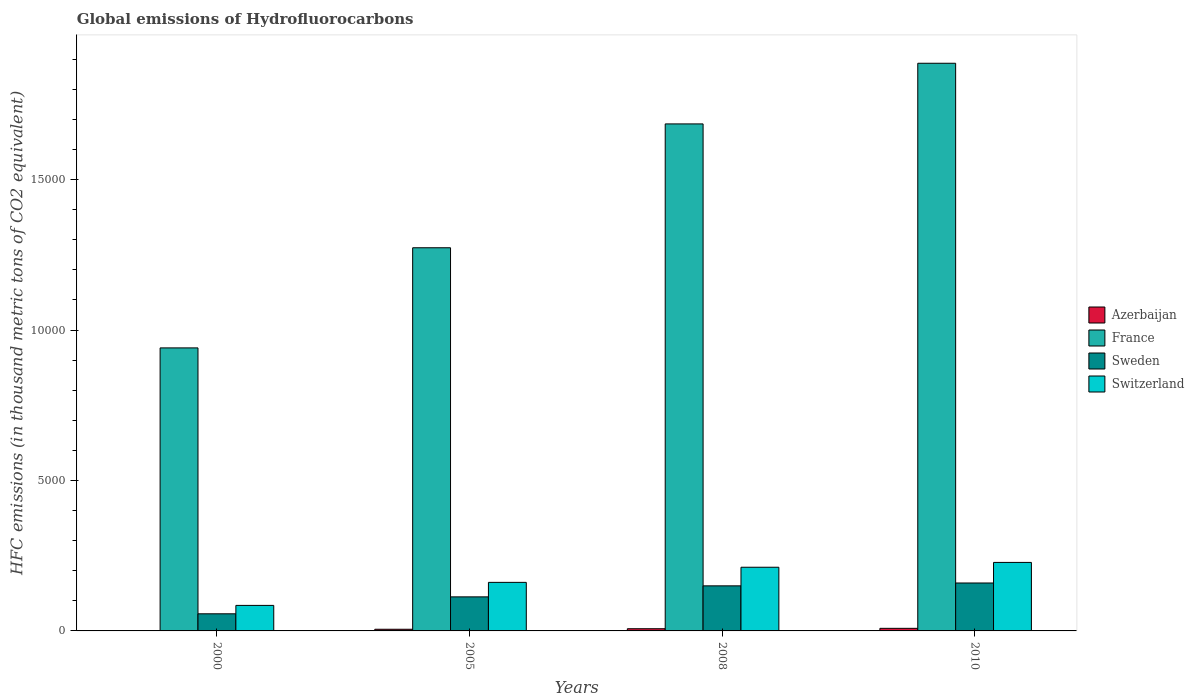How many groups of bars are there?
Offer a terse response. 4. Are the number of bars per tick equal to the number of legend labels?
Your response must be concise. Yes. Are the number of bars on each tick of the X-axis equal?
Offer a terse response. Yes. What is the label of the 1st group of bars from the left?
Keep it short and to the point. 2000. In how many cases, is the number of bars for a given year not equal to the number of legend labels?
Give a very brief answer. 0. What is the global emissions of Hydrofluorocarbons in Switzerland in 2010?
Offer a very short reply. 2277. Across all years, what is the minimum global emissions of Hydrofluorocarbons in Sweden?
Ensure brevity in your answer.  568.8. What is the total global emissions of Hydrofluorocarbons in Switzerland in the graph?
Ensure brevity in your answer.  6855.4. What is the difference between the global emissions of Hydrofluorocarbons in Azerbaijan in 2000 and that in 2008?
Offer a terse response. -64.6. What is the difference between the global emissions of Hydrofluorocarbons in Switzerland in 2000 and the global emissions of Hydrofluorocarbons in Sweden in 2008?
Your answer should be very brief. -649.8. What is the average global emissions of Hydrofluorocarbons in Switzerland per year?
Your answer should be compact. 1713.85. In the year 2010, what is the difference between the global emissions of Hydrofluorocarbons in Switzerland and global emissions of Hydrofluorocarbons in Azerbaijan?
Ensure brevity in your answer.  2191. What is the ratio of the global emissions of Hydrofluorocarbons in Azerbaijan in 2000 to that in 2005?
Make the answer very short. 0.15. Is the difference between the global emissions of Hydrofluorocarbons in Switzerland in 2000 and 2005 greater than the difference between the global emissions of Hydrofluorocarbons in Azerbaijan in 2000 and 2005?
Your answer should be very brief. No. What is the difference between the highest and the second highest global emissions of Hydrofluorocarbons in Azerbaijan?
Your answer should be compact. 12.9. What is the difference between the highest and the lowest global emissions of Hydrofluorocarbons in Switzerland?
Offer a very short reply. 1428.8. In how many years, is the global emissions of Hydrofluorocarbons in France greater than the average global emissions of Hydrofluorocarbons in France taken over all years?
Make the answer very short. 2. Is it the case that in every year, the sum of the global emissions of Hydrofluorocarbons in Azerbaijan and global emissions of Hydrofluorocarbons in Switzerland is greater than the sum of global emissions of Hydrofluorocarbons in Sweden and global emissions of Hydrofluorocarbons in France?
Your response must be concise. Yes. What does the 1st bar from the left in 2005 represents?
Give a very brief answer. Azerbaijan. Are all the bars in the graph horizontal?
Your answer should be very brief. No. Are the values on the major ticks of Y-axis written in scientific E-notation?
Give a very brief answer. No. Does the graph contain any zero values?
Your response must be concise. No. What is the title of the graph?
Make the answer very short. Global emissions of Hydrofluorocarbons. What is the label or title of the Y-axis?
Keep it short and to the point. HFC emissions (in thousand metric tons of CO2 equivalent). What is the HFC emissions (in thousand metric tons of CO2 equivalent) in Azerbaijan in 2000?
Provide a succinct answer. 8.5. What is the HFC emissions (in thousand metric tons of CO2 equivalent) in France in 2000?
Keep it short and to the point. 9406.4. What is the HFC emissions (in thousand metric tons of CO2 equivalent) of Sweden in 2000?
Keep it short and to the point. 568.8. What is the HFC emissions (in thousand metric tons of CO2 equivalent) of Switzerland in 2000?
Your response must be concise. 848.2. What is the HFC emissions (in thousand metric tons of CO2 equivalent) in Azerbaijan in 2005?
Offer a very short reply. 55.4. What is the HFC emissions (in thousand metric tons of CO2 equivalent) in France in 2005?
Keep it short and to the point. 1.27e+04. What is the HFC emissions (in thousand metric tons of CO2 equivalent) in Sweden in 2005?
Ensure brevity in your answer.  1131.9. What is the HFC emissions (in thousand metric tons of CO2 equivalent) in Switzerland in 2005?
Make the answer very short. 1613.8. What is the HFC emissions (in thousand metric tons of CO2 equivalent) in Azerbaijan in 2008?
Make the answer very short. 73.1. What is the HFC emissions (in thousand metric tons of CO2 equivalent) of France in 2008?
Provide a short and direct response. 1.69e+04. What is the HFC emissions (in thousand metric tons of CO2 equivalent) of Sweden in 2008?
Ensure brevity in your answer.  1498. What is the HFC emissions (in thousand metric tons of CO2 equivalent) of Switzerland in 2008?
Provide a succinct answer. 2116.4. What is the HFC emissions (in thousand metric tons of CO2 equivalent) of France in 2010?
Your response must be concise. 1.89e+04. What is the HFC emissions (in thousand metric tons of CO2 equivalent) in Sweden in 2010?
Give a very brief answer. 1593. What is the HFC emissions (in thousand metric tons of CO2 equivalent) in Switzerland in 2010?
Ensure brevity in your answer.  2277. Across all years, what is the maximum HFC emissions (in thousand metric tons of CO2 equivalent) of Azerbaijan?
Ensure brevity in your answer.  86. Across all years, what is the maximum HFC emissions (in thousand metric tons of CO2 equivalent) in France?
Offer a terse response. 1.89e+04. Across all years, what is the maximum HFC emissions (in thousand metric tons of CO2 equivalent) of Sweden?
Your answer should be very brief. 1593. Across all years, what is the maximum HFC emissions (in thousand metric tons of CO2 equivalent) of Switzerland?
Your answer should be very brief. 2277. Across all years, what is the minimum HFC emissions (in thousand metric tons of CO2 equivalent) in Azerbaijan?
Give a very brief answer. 8.5. Across all years, what is the minimum HFC emissions (in thousand metric tons of CO2 equivalent) of France?
Your answer should be compact. 9406.4. Across all years, what is the minimum HFC emissions (in thousand metric tons of CO2 equivalent) of Sweden?
Provide a succinct answer. 568.8. Across all years, what is the minimum HFC emissions (in thousand metric tons of CO2 equivalent) of Switzerland?
Your response must be concise. 848.2. What is the total HFC emissions (in thousand metric tons of CO2 equivalent) in Azerbaijan in the graph?
Your answer should be compact. 223. What is the total HFC emissions (in thousand metric tons of CO2 equivalent) in France in the graph?
Offer a terse response. 5.79e+04. What is the total HFC emissions (in thousand metric tons of CO2 equivalent) of Sweden in the graph?
Your answer should be very brief. 4791.7. What is the total HFC emissions (in thousand metric tons of CO2 equivalent) in Switzerland in the graph?
Provide a short and direct response. 6855.4. What is the difference between the HFC emissions (in thousand metric tons of CO2 equivalent) of Azerbaijan in 2000 and that in 2005?
Make the answer very short. -46.9. What is the difference between the HFC emissions (in thousand metric tons of CO2 equivalent) in France in 2000 and that in 2005?
Keep it short and to the point. -3328.3. What is the difference between the HFC emissions (in thousand metric tons of CO2 equivalent) in Sweden in 2000 and that in 2005?
Provide a short and direct response. -563.1. What is the difference between the HFC emissions (in thousand metric tons of CO2 equivalent) in Switzerland in 2000 and that in 2005?
Your answer should be compact. -765.6. What is the difference between the HFC emissions (in thousand metric tons of CO2 equivalent) of Azerbaijan in 2000 and that in 2008?
Offer a very short reply. -64.6. What is the difference between the HFC emissions (in thousand metric tons of CO2 equivalent) in France in 2000 and that in 2008?
Offer a very short reply. -7444.7. What is the difference between the HFC emissions (in thousand metric tons of CO2 equivalent) in Sweden in 2000 and that in 2008?
Make the answer very short. -929.2. What is the difference between the HFC emissions (in thousand metric tons of CO2 equivalent) of Switzerland in 2000 and that in 2008?
Your response must be concise. -1268.2. What is the difference between the HFC emissions (in thousand metric tons of CO2 equivalent) in Azerbaijan in 2000 and that in 2010?
Offer a very short reply. -77.5. What is the difference between the HFC emissions (in thousand metric tons of CO2 equivalent) in France in 2000 and that in 2010?
Provide a succinct answer. -9460.6. What is the difference between the HFC emissions (in thousand metric tons of CO2 equivalent) in Sweden in 2000 and that in 2010?
Your answer should be very brief. -1024.2. What is the difference between the HFC emissions (in thousand metric tons of CO2 equivalent) of Switzerland in 2000 and that in 2010?
Provide a succinct answer. -1428.8. What is the difference between the HFC emissions (in thousand metric tons of CO2 equivalent) of Azerbaijan in 2005 and that in 2008?
Offer a terse response. -17.7. What is the difference between the HFC emissions (in thousand metric tons of CO2 equivalent) of France in 2005 and that in 2008?
Give a very brief answer. -4116.4. What is the difference between the HFC emissions (in thousand metric tons of CO2 equivalent) of Sweden in 2005 and that in 2008?
Offer a very short reply. -366.1. What is the difference between the HFC emissions (in thousand metric tons of CO2 equivalent) of Switzerland in 2005 and that in 2008?
Your response must be concise. -502.6. What is the difference between the HFC emissions (in thousand metric tons of CO2 equivalent) in Azerbaijan in 2005 and that in 2010?
Your answer should be compact. -30.6. What is the difference between the HFC emissions (in thousand metric tons of CO2 equivalent) in France in 2005 and that in 2010?
Give a very brief answer. -6132.3. What is the difference between the HFC emissions (in thousand metric tons of CO2 equivalent) in Sweden in 2005 and that in 2010?
Give a very brief answer. -461.1. What is the difference between the HFC emissions (in thousand metric tons of CO2 equivalent) in Switzerland in 2005 and that in 2010?
Your answer should be very brief. -663.2. What is the difference between the HFC emissions (in thousand metric tons of CO2 equivalent) of France in 2008 and that in 2010?
Offer a very short reply. -2015.9. What is the difference between the HFC emissions (in thousand metric tons of CO2 equivalent) in Sweden in 2008 and that in 2010?
Make the answer very short. -95. What is the difference between the HFC emissions (in thousand metric tons of CO2 equivalent) in Switzerland in 2008 and that in 2010?
Ensure brevity in your answer.  -160.6. What is the difference between the HFC emissions (in thousand metric tons of CO2 equivalent) in Azerbaijan in 2000 and the HFC emissions (in thousand metric tons of CO2 equivalent) in France in 2005?
Offer a terse response. -1.27e+04. What is the difference between the HFC emissions (in thousand metric tons of CO2 equivalent) in Azerbaijan in 2000 and the HFC emissions (in thousand metric tons of CO2 equivalent) in Sweden in 2005?
Ensure brevity in your answer.  -1123.4. What is the difference between the HFC emissions (in thousand metric tons of CO2 equivalent) of Azerbaijan in 2000 and the HFC emissions (in thousand metric tons of CO2 equivalent) of Switzerland in 2005?
Offer a terse response. -1605.3. What is the difference between the HFC emissions (in thousand metric tons of CO2 equivalent) in France in 2000 and the HFC emissions (in thousand metric tons of CO2 equivalent) in Sweden in 2005?
Give a very brief answer. 8274.5. What is the difference between the HFC emissions (in thousand metric tons of CO2 equivalent) of France in 2000 and the HFC emissions (in thousand metric tons of CO2 equivalent) of Switzerland in 2005?
Provide a succinct answer. 7792.6. What is the difference between the HFC emissions (in thousand metric tons of CO2 equivalent) in Sweden in 2000 and the HFC emissions (in thousand metric tons of CO2 equivalent) in Switzerland in 2005?
Provide a succinct answer. -1045. What is the difference between the HFC emissions (in thousand metric tons of CO2 equivalent) of Azerbaijan in 2000 and the HFC emissions (in thousand metric tons of CO2 equivalent) of France in 2008?
Ensure brevity in your answer.  -1.68e+04. What is the difference between the HFC emissions (in thousand metric tons of CO2 equivalent) in Azerbaijan in 2000 and the HFC emissions (in thousand metric tons of CO2 equivalent) in Sweden in 2008?
Offer a terse response. -1489.5. What is the difference between the HFC emissions (in thousand metric tons of CO2 equivalent) of Azerbaijan in 2000 and the HFC emissions (in thousand metric tons of CO2 equivalent) of Switzerland in 2008?
Your answer should be very brief. -2107.9. What is the difference between the HFC emissions (in thousand metric tons of CO2 equivalent) of France in 2000 and the HFC emissions (in thousand metric tons of CO2 equivalent) of Sweden in 2008?
Your answer should be very brief. 7908.4. What is the difference between the HFC emissions (in thousand metric tons of CO2 equivalent) in France in 2000 and the HFC emissions (in thousand metric tons of CO2 equivalent) in Switzerland in 2008?
Keep it short and to the point. 7290. What is the difference between the HFC emissions (in thousand metric tons of CO2 equivalent) in Sweden in 2000 and the HFC emissions (in thousand metric tons of CO2 equivalent) in Switzerland in 2008?
Your answer should be very brief. -1547.6. What is the difference between the HFC emissions (in thousand metric tons of CO2 equivalent) of Azerbaijan in 2000 and the HFC emissions (in thousand metric tons of CO2 equivalent) of France in 2010?
Provide a succinct answer. -1.89e+04. What is the difference between the HFC emissions (in thousand metric tons of CO2 equivalent) of Azerbaijan in 2000 and the HFC emissions (in thousand metric tons of CO2 equivalent) of Sweden in 2010?
Ensure brevity in your answer.  -1584.5. What is the difference between the HFC emissions (in thousand metric tons of CO2 equivalent) in Azerbaijan in 2000 and the HFC emissions (in thousand metric tons of CO2 equivalent) in Switzerland in 2010?
Give a very brief answer. -2268.5. What is the difference between the HFC emissions (in thousand metric tons of CO2 equivalent) in France in 2000 and the HFC emissions (in thousand metric tons of CO2 equivalent) in Sweden in 2010?
Make the answer very short. 7813.4. What is the difference between the HFC emissions (in thousand metric tons of CO2 equivalent) in France in 2000 and the HFC emissions (in thousand metric tons of CO2 equivalent) in Switzerland in 2010?
Ensure brevity in your answer.  7129.4. What is the difference between the HFC emissions (in thousand metric tons of CO2 equivalent) of Sweden in 2000 and the HFC emissions (in thousand metric tons of CO2 equivalent) of Switzerland in 2010?
Offer a very short reply. -1708.2. What is the difference between the HFC emissions (in thousand metric tons of CO2 equivalent) of Azerbaijan in 2005 and the HFC emissions (in thousand metric tons of CO2 equivalent) of France in 2008?
Offer a very short reply. -1.68e+04. What is the difference between the HFC emissions (in thousand metric tons of CO2 equivalent) of Azerbaijan in 2005 and the HFC emissions (in thousand metric tons of CO2 equivalent) of Sweden in 2008?
Provide a short and direct response. -1442.6. What is the difference between the HFC emissions (in thousand metric tons of CO2 equivalent) in Azerbaijan in 2005 and the HFC emissions (in thousand metric tons of CO2 equivalent) in Switzerland in 2008?
Offer a very short reply. -2061. What is the difference between the HFC emissions (in thousand metric tons of CO2 equivalent) in France in 2005 and the HFC emissions (in thousand metric tons of CO2 equivalent) in Sweden in 2008?
Ensure brevity in your answer.  1.12e+04. What is the difference between the HFC emissions (in thousand metric tons of CO2 equivalent) of France in 2005 and the HFC emissions (in thousand metric tons of CO2 equivalent) of Switzerland in 2008?
Provide a short and direct response. 1.06e+04. What is the difference between the HFC emissions (in thousand metric tons of CO2 equivalent) of Sweden in 2005 and the HFC emissions (in thousand metric tons of CO2 equivalent) of Switzerland in 2008?
Provide a short and direct response. -984.5. What is the difference between the HFC emissions (in thousand metric tons of CO2 equivalent) in Azerbaijan in 2005 and the HFC emissions (in thousand metric tons of CO2 equivalent) in France in 2010?
Make the answer very short. -1.88e+04. What is the difference between the HFC emissions (in thousand metric tons of CO2 equivalent) of Azerbaijan in 2005 and the HFC emissions (in thousand metric tons of CO2 equivalent) of Sweden in 2010?
Offer a very short reply. -1537.6. What is the difference between the HFC emissions (in thousand metric tons of CO2 equivalent) in Azerbaijan in 2005 and the HFC emissions (in thousand metric tons of CO2 equivalent) in Switzerland in 2010?
Ensure brevity in your answer.  -2221.6. What is the difference between the HFC emissions (in thousand metric tons of CO2 equivalent) of France in 2005 and the HFC emissions (in thousand metric tons of CO2 equivalent) of Sweden in 2010?
Provide a short and direct response. 1.11e+04. What is the difference between the HFC emissions (in thousand metric tons of CO2 equivalent) in France in 2005 and the HFC emissions (in thousand metric tons of CO2 equivalent) in Switzerland in 2010?
Provide a short and direct response. 1.05e+04. What is the difference between the HFC emissions (in thousand metric tons of CO2 equivalent) of Sweden in 2005 and the HFC emissions (in thousand metric tons of CO2 equivalent) of Switzerland in 2010?
Your answer should be very brief. -1145.1. What is the difference between the HFC emissions (in thousand metric tons of CO2 equivalent) in Azerbaijan in 2008 and the HFC emissions (in thousand metric tons of CO2 equivalent) in France in 2010?
Make the answer very short. -1.88e+04. What is the difference between the HFC emissions (in thousand metric tons of CO2 equivalent) in Azerbaijan in 2008 and the HFC emissions (in thousand metric tons of CO2 equivalent) in Sweden in 2010?
Offer a terse response. -1519.9. What is the difference between the HFC emissions (in thousand metric tons of CO2 equivalent) in Azerbaijan in 2008 and the HFC emissions (in thousand metric tons of CO2 equivalent) in Switzerland in 2010?
Keep it short and to the point. -2203.9. What is the difference between the HFC emissions (in thousand metric tons of CO2 equivalent) in France in 2008 and the HFC emissions (in thousand metric tons of CO2 equivalent) in Sweden in 2010?
Provide a short and direct response. 1.53e+04. What is the difference between the HFC emissions (in thousand metric tons of CO2 equivalent) in France in 2008 and the HFC emissions (in thousand metric tons of CO2 equivalent) in Switzerland in 2010?
Your answer should be very brief. 1.46e+04. What is the difference between the HFC emissions (in thousand metric tons of CO2 equivalent) of Sweden in 2008 and the HFC emissions (in thousand metric tons of CO2 equivalent) of Switzerland in 2010?
Your response must be concise. -779. What is the average HFC emissions (in thousand metric tons of CO2 equivalent) of Azerbaijan per year?
Your answer should be very brief. 55.75. What is the average HFC emissions (in thousand metric tons of CO2 equivalent) in France per year?
Give a very brief answer. 1.45e+04. What is the average HFC emissions (in thousand metric tons of CO2 equivalent) of Sweden per year?
Your answer should be very brief. 1197.92. What is the average HFC emissions (in thousand metric tons of CO2 equivalent) of Switzerland per year?
Provide a succinct answer. 1713.85. In the year 2000, what is the difference between the HFC emissions (in thousand metric tons of CO2 equivalent) of Azerbaijan and HFC emissions (in thousand metric tons of CO2 equivalent) of France?
Make the answer very short. -9397.9. In the year 2000, what is the difference between the HFC emissions (in thousand metric tons of CO2 equivalent) of Azerbaijan and HFC emissions (in thousand metric tons of CO2 equivalent) of Sweden?
Offer a very short reply. -560.3. In the year 2000, what is the difference between the HFC emissions (in thousand metric tons of CO2 equivalent) of Azerbaijan and HFC emissions (in thousand metric tons of CO2 equivalent) of Switzerland?
Offer a terse response. -839.7. In the year 2000, what is the difference between the HFC emissions (in thousand metric tons of CO2 equivalent) in France and HFC emissions (in thousand metric tons of CO2 equivalent) in Sweden?
Your answer should be compact. 8837.6. In the year 2000, what is the difference between the HFC emissions (in thousand metric tons of CO2 equivalent) in France and HFC emissions (in thousand metric tons of CO2 equivalent) in Switzerland?
Your answer should be very brief. 8558.2. In the year 2000, what is the difference between the HFC emissions (in thousand metric tons of CO2 equivalent) in Sweden and HFC emissions (in thousand metric tons of CO2 equivalent) in Switzerland?
Provide a short and direct response. -279.4. In the year 2005, what is the difference between the HFC emissions (in thousand metric tons of CO2 equivalent) in Azerbaijan and HFC emissions (in thousand metric tons of CO2 equivalent) in France?
Offer a terse response. -1.27e+04. In the year 2005, what is the difference between the HFC emissions (in thousand metric tons of CO2 equivalent) of Azerbaijan and HFC emissions (in thousand metric tons of CO2 equivalent) of Sweden?
Your answer should be very brief. -1076.5. In the year 2005, what is the difference between the HFC emissions (in thousand metric tons of CO2 equivalent) of Azerbaijan and HFC emissions (in thousand metric tons of CO2 equivalent) of Switzerland?
Make the answer very short. -1558.4. In the year 2005, what is the difference between the HFC emissions (in thousand metric tons of CO2 equivalent) of France and HFC emissions (in thousand metric tons of CO2 equivalent) of Sweden?
Keep it short and to the point. 1.16e+04. In the year 2005, what is the difference between the HFC emissions (in thousand metric tons of CO2 equivalent) of France and HFC emissions (in thousand metric tons of CO2 equivalent) of Switzerland?
Offer a very short reply. 1.11e+04. In the year 2005, what is the difference between the HFC emissions (in thousand metric tons of CO2 equivalent) of Sweden and HFC emissions (in thousand metric tons of CO2 equivalent) of Switzerland?
Provide a short and direct response. -481.9. In the year 2008, what is the difference between the HFC emissions (in thousand metric tons of CO2 equivalent) of Azerbaijan and HFC emissions (in thousand metric tons of CO2 equivalent) of France?
Make the answer very short. -1.68e+04. In the year 2008, what is the difference between the HFC emissions (in thousand metric tons of CO2 equivalent) in Azerbaijan and HFC emissions (in thousand metric tons of CO2 equivalent) in Sweden?
Ensure brevity in your answer.  -1424.9. In the year 2008, what is the difference between the HFC emissions (in thousand metric tons of CO2 equivalent) in Azerbaijan and HFC emissions (in thousand metric tons of CO2 equivalent) in Switzerland?
Give a very brief answer. -2043.3. In the year 2008, what is the difference between the HFC emissions (in thousand metric tons of CO2 equivalent) in France and HFC emissions (in thousand metric tons of CO2 equivalent) in Sweden?
Your answer should be very brief. 1.54e+04. In the year 2008, what is the difference between the HFC emissions (in thousand metric tons of CO2 equivalent) of France and HFC emissions (in thousand metric tons of CO2 equivalent) of Switzerland?
Your response must be concise. 1.47e+04. In the year 2008, what is the difference between the HFC emissions (in thousand metric tons of CO2 equivalent) of Sweden and HFC emissions (in thousand metric tons of CO2 equivalent) of Switzerland?
Ensure brevity in your answer.  -618.4. In the year 2010, what is the difference between the HFC emissions (in thousand metric tons of CO2 equivalent) in Azerbaijan and HFC emissions (in thousand metric tons of CO2 equivalent) in France?
Keep it short and to the point. -1.88e+04. In the year 2010, what is the difference between the HFC emissions (in thousand metric tons of CO2 equivalent) of Azerbaijan and HFC emissions (in thousand metric tons of CO2 equivalent) of Sweden?
Your answer should be very brief. -1507. In the year 2010, what is the difference between the HFC emissions (in thousand metric tons of CO2 equivalent) of Azerbaijan and HFC emissions (in thousand metric tons of CO2 equivalent) of Switzerland?
Your answer should be very brief. -2191. In the year 2010, what is the difference between the HFC emissions (in thousand metric tons of CO2 equivalent) in France and HFC emissions (in thousand metric tons of CO2 equivalent) in Sweden?
Keep it short and to the point. 1.73e+04. In the year 2010, what is the difference between the HFC emissions (in thousand metric tons of CO2 equivalent) in France and HFC emissions (in thousand metric tons of CO2 equivalent) in Switzerland?
Keep it short and to the point. 1.66e+04. In the year 2010, what is the difference between the HFC emissions (in thousand metric tons of CO2 equivalent) in Sweden and HFC emissions (in thousand metric tons of CO2 equivalent) in Switzerland?
Provide a succinct answer. -684. What is the ratio of the HFC emissions (in thousand metric tons of CO2 equivalent) in Azerbaijan in 2000 to that in 2005?
Provide a short and direct response. 0.15. What is the ratio of the HFC emissions (in thousand metric tons of CO2 equivalent) of France in 2000 to that in 2005?
Ensure brevity in your answer.  0.74. What is the ratio of the HFC emissions (in thousand metric tons of CO2 equivalent) of Sweden in 2000 to that in 2005?
Offer a terse response. 0.5. What is the ratio of the HFC emissions (in thousand metric tons of CO2 equivalent) in Switzerland in 2000 to that in 2005?
Make the answer very short. 0.53. What is the ratio of the HFC emissions (in thousand metric tons of CO2 equivalent) in Azerbaijan in 2000 to that in 2008?
Provide a short and direct response. 0.12. What is the ratio of the HFC emissions (in thousand metric tons of CO2 equivalent) in France in 2000 to that in 2008?
Keep it short and to the point. 0.56. What is the ratio of the HFC emissions (in thousand metric tons of CO2 equivalent) in Sweden in 2000 to that in 2008?
Make the answer very short. 0.38. What is the ratio of the HFC emissions (in thousand metric tons of CO2 equivalent) of Switzerland in 2000 to that in 2008?
Make the answer very short. 0.4. What is the ratio of the HFC emissions (in thousand metric tons of CO2 equivalent) in Azerbaijan in 2000 to that in 2010?
Provide a succinct answer. 0.1. What is the ratio of the HFC emissions (in thousand metric tons of CO2 equivalent) of France in 2000 to that in 2010?
Provide a succinct answer. 0.5. What is the ratio of the HFC emissions (in thousand metric tons of CO2 equivalent) of Sweden in 2000 to that in 2010?
Your answer should be compact. 0.36. What is the ratio of the HFC emissions (in thousand metric tons of CO2 equivalent) in Switzerland in 2000 to that in 2010?
Keep it short and to the point. 0.37. What is the ratio of the HFC emissions (in thousand metric tons of CO2 equivalent) in Azerbaijan in 2005 to that in 2008?
Ensure brevity in your answer.  0.76. What is the ratio of the HFC emissions (in thousand metric tons of CO2 equivalent) of France in 2005 to that in 2008?
Offer a terse response. 0.76. What is the ratio of the HFC emissions (in thousand metric tons of CO2 equivalent) in Sweden in 2005 to that in 2008?
Make the answer very short. 0.76. What is the ratio of the HFC emissions (in thousand metric tons of CO2 equivalent) in Switzerland in 2005 to that in 2008?
Offer a terse response. 0.76. What is the ratio of the HFC emissions (in thousand metric tons of CO2 equivalent) of Azerbaijan in 2005 to that in 2010?
Your response must be concise. 0.64. What is the ratio of the HFC emissions (in thousand metric tons of CO2 equivalent) in France in 2005 to that in 2010?
Provide a succinct answer. 0.68. What is the ratio of the HFC emissions (in thousand metric tons of CO2 equivalent) of Sweden in 2005 to that in 2010?
Make the answer very short. 0.71. What is the ratio of the HFC emissions (in thousand metric tons of CO2 equivalent) in Switzerland in 2005 to that in 2010?
Provide a succinct answer. 0.71. What is the ratio of the HFC emissions (in thousand metric tons of CO2 equivalent) of France in 2008 to that in 2010?
Offer a terse response. 0.89. What is the ratio of the HFC emissions (in thousand metric tons of CO2 equivalent) in Sweden in 2008 to that in 2010?
Ensure brevity in your answer.  0.94. What is the ratio of the HFC emissions (in thousand metric tons of CO2 equivalent) in Switzerland in 2008 to that in 2010?
Provide a short and direct response. 0.93. What is the difference between the highest and the second highest HFC emissions (in thousand metric tons of CO2 equivalent) of France?
Give a very brief answer. 2015.9. What is the difference between the highest and the second highest HFC emissions (in thousand metric tons of CO2 equivalent) in Switzerland?
Make the answer very short. 160.6. What is the difference between the highest and the lowest HFC emissions (in thousand metric tons of CO2 equivalent) of Azerbaijan?
Ensure brevity in your answer.  77.5. What is the difference between the highest and the lowest HFC emissions (in thousand metric tons of CO2 equivalent) of France?
Offer a terse response. 9460.6. What is the difference between the highest and the lowest HFC emissions (in thousand metric tons of CO2 equivalent) of Sweden?
Make the answer very short. 1024.2. What is the difference between the highest and the lowest HFC emissions (in thousand metric tons of CO2 equivalent) of Switzerland?
Provide a short and direct response. 1428.8. 